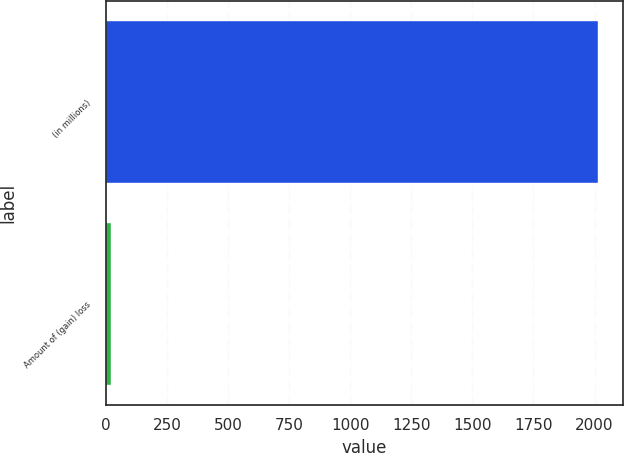<chart> <loc_0><loc_0><loc_500><loc_500><bar_chart><fcel>(in millions)<fcel>Amount of (gain) loss<nl><fcel>2015<fcel>19<nl></chart> 